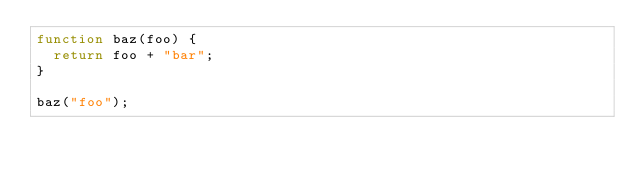Convert code to text. <code><loc_0><loc_0><loc_500><loc_500><_JavaScript_>function baz(foo) { 
  return foo + "bar";
}

baz("foo");
</code> 